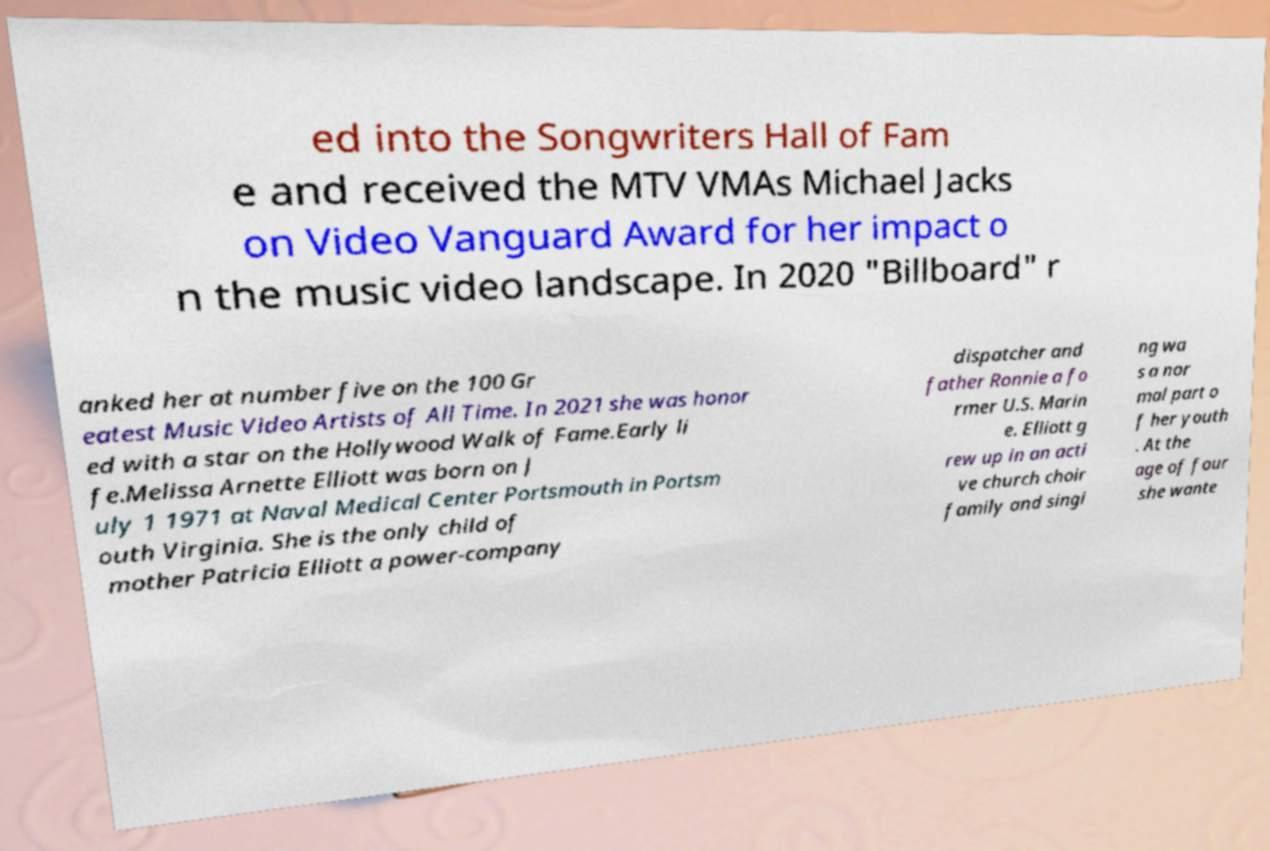Please read and relay the text visible in this image. What does it say? ed into the Songwriters Hall of Fam e and received the MTV VMAs Michael Jacks on Video Vanguard Award for her impact o n the music video landscape. In 2020 "Billboard" r anked her at number five on the 100 Gr eatest Music Video Artists of All Time. In 2021 she was honor ed with a star on the Hollywood Walk of Fame.Early li fe.Melissa Arnette Elliott was born on J uly 1 1971 at Naval Medical Center Portsmouth in Portsm outh Virginia. She is the only child of mother Patricia Elliott a power-company dispatcher and father Ronnie a fo rmer U.S. Marin e. Elliott g rew up in an acti ve church choir family and singi ng wa s a nor mal part o f her youth . At the age of four she wante 